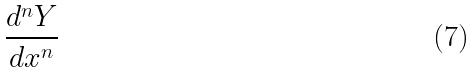<formula> <loc_0><loc_0><loc_500><loc_500>\frac { d ^ { n } Y } { d x ^ { n } }</formula> 